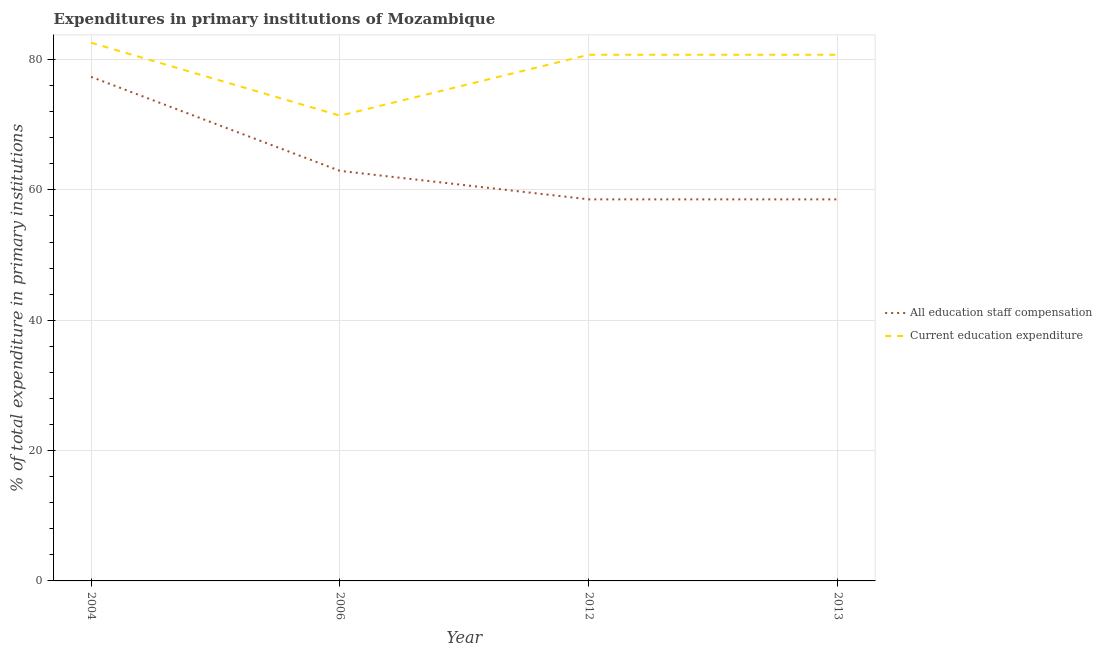Does the line corresponding to expenditure in staff compensation intersect with the line corresponding to expenditure in education?
Ensure brevity in your answer.  No. Is the number of lines equal to the number of legend labels?
Offer a terse response. Yes. What is the expenditure in staff compensation in 2012?
Your response must be concise. 58.55. Across all years, what is the maximum expenditure in staff compensation?
Ensure brevity in your answer.  77.35. Across all years, what is the minimum expenditure in education?
Make the answer very short. 71.39. In which year was the expenditure in education maximum?
Make the answer very short. 2004. What is the total expenditure in education in the graph?
Offer a very short reply. 315.46. What is the difference between the expenditure in staff compensation in 2004 and that in 2006?
Provide a short and direct response. 14.43. What is the difference between the expenditure in education in 2004 and the expenditure in staff compensation in 2013?
Your answer should be compact. 24.04. What is the average expenditure in education per year?
Provide a short and direct response. 78.87. In the year 2013, what is the difference between the expenditure in staff compensation and expenditure in education?
Provide a succinct answer. -22.19. What is the ratio of the expenditure in staff compensation in 2006 to that in 2012?
Keep it short and to the point. 1.07. Is the difference between the expenditure in staff compensation in 2004 and 2006 greater than the difference between the expenditure in education in 2004 and 2006?
Make the answer very short. Yes. What is the difference between the highest and the second highest expenditure in education?
Offer a terse response. 1.85. What is the difference between the highest and the lowest expenditure in staff compensation?
Offer a terse response. 18.8. In how many years, is the expenditure in education greater than the average expenditure in education taken over all years?
Offer a very short reply. 3. How many years are there in the graph?
Give a very brief answer. 4. What is the difference between two consecutive major ticks on the Y-axis?
Your response must be concise. 20. Does the graph contain grids?
Provide a succinct answer. Yes. Where does the legend appear in the graph?
Offer a very short reply. Center right. How are the legend labels stacked?
Your answer should be compact. Vertical. What is the title of the graph?
Offer a terse response. Expenditures in primary institutions of Mozambique. What is the label or title of the Y-axis?
Ensure brevity in your answer.  % of total expenditure in primary institutions. What is the % of total expenditure in primary institutions of All education staff compensation in 2004?
Make the answer very short. 77.35. What is the % of total expenditure in primary institutions of Current education expenditure in 2004?
Provide a succinct answer. 82.59. What is the % of total expenditure in primary institutions of All education staff compensation in 2006?
Offer a very short reply. 62.92. What is the % of total expenditure in primary institutions in Current education expenditure in 2006?
Offer a very short reply. 71.39. What is the % of total expenditure in primary institutions of All education staff compensation in 2012?
Provide a succinct answer. 58.55. What is the % of total expenditure in primary institutions of Current education expenditure in 2012?
Your response must be concise. 80.74. What is the % of total expenditure in primary institutions in All education staff compensation in 2013?
Your answer should be compact. 58.55. What is the % of total expenditure in primary institutions of Current education expenditure in 2013?
Your answer should be very brief. 80.74. Across all years, what is the maximum % of total expenditure in primary institutions of All education staff compensation?
Keep it short and to the point. 77.35. Across all years, what is the maximum % of total expenditure in primary institutions in Current education expenditure?
Provide a succinct answer. 82.59. Across all years, what is the minimum % of total expenditure in primary institutions in All education staff compensation?
Provide a succinct answer. 58.55. Across all years, what is the minimum % of total expenditure in primary institutions in Current education expenditure?
Give a very brief answer. 71.39. What is the total % of total expenditure in primary institutions in All education staff compensation in the graph?
Make the answer very short. 257.37. What is the total % of total expenditure in primary institutions of Current education expenditure in the graph?
Offer a very short reply. 315.46. What is the difference between the % of total expenditure in primary institutions of All education staff compensation in 2004 and that in 2006?
Give a very brief answer. 14.43. What is the difference between the % of total expenditure in primary institutions in Current education expenditure in 2004 and that in 2006?
Offer a terse response. 11.19. What is the difference between the % of total expenditure in primary institutions in All education staff compensation in 2004 and that in 2012?
Give a very brief answer. 18.8. What is the difference between the % of total expenditure in primary institutions in Current education expenditure in 2004 and that in 2012?
Ensure brevity in your answer.  1.85. What is the difference between the % of total expenditure in primary institutions of All education staff compensation in 2004 and that in 2013?
Ensure brevity in your answer.  18.8. What is the difference between the % of total expenditure in primary institutions of Current education expenditure in 2004 and that in 2013?
Provide a succinct answer. 1.85. What is the difference between the % of total expenditure in primary institutions in All education staff compensation in 2006 and that in 2012?
Provide a succinct answer. 4.37. What is the difference between the % of total expenditure in primary institutions in Current education expenditure in 2006 and that in 2012?
Provide a succinct answer. -9.35. What is the difference between the % of total expenditure in primary institutions of All education staff compensation in 2006 and that in 2013?
Make the answer very short. 4.37. What is the difference between the % of total expenditure in primary institutions in Current education expenditure in 2006 and that in 2013?
Offer a very short reply. -9.35. What is the difference between the % of total expenditure in primary institutions in All education staff compensation in 2012 and that in 2013?
Ensure brevity in your answer.  0. What is the difference between the % of total expenditure in primary institutions of All education staff compensation in 2004 and the % of total expenditure in primary institutions of Current education expenditure in 2006?
Ensure brevity in your answer.  5.96. What is the difference between the % of total expenditure in primary institutions in All education staff compensation in 2004 and the % of total expenditure in primary institutions in Current education expenditure in 2012?
Offer a very short reply. -3.39. What is the difference between the % of total expenditure in primary institutions in All education staff compensation in 2004 and the % of total expenditure in primary institutions in Current education expenditure in 2013?
Keep it short and to the point. -3.39. What is the difference between the % of total expenditure in primary institutions in All education staff compensation in 2006 and the % of total expenditure in primary institutions in Current education expenditure in 2012?
Your answer should be very brief. -17.82. What is the difference between the % of total expenditure in primary institutions of All education staff compensation in 2006 and the % of total expenditure in primary institutions of Current education expenditure in 2013?
Ensure brevity in your answer.  -17.82. What is the difference between the % of total expenditure in primary institutions in All education staff compensation in 2012 and the % of total expenditure in primary institutions in Current education expenditure in 2013?
Your answer should be very brief. -22.19. What is the average % of total expenditure in primary institutions of All education staff compensation per year?
Offer a terse response. 64.34. What is the average % of total expenditure in primary institutions in Current education expenditure per year?
Offer a very short reply. 78.87. In the year 2004, what is the difference between the % of total expenditure in primary institutions of All education staff compensation and % of total expenditure in primary institutions of Current education expenditure?
Give a very brief answer. -5.24. In the year 2006, what is the difference between the % of total expenditure in primary institutions in All education staff compensation and % of total expenditure in primary institutions in Current education expenditure?
Your answer should be compact. -8.47. In the year 2012, what is the difference between the % of total expenditure in primary institutions of All education staff compensation and % of total expenditure in primary institutions of Current education expenditure?
Keep it short and to the point. -22.19. In the year 2013, what is the difference between the % of total expenditure in primary institutions in All education staff compensation and % of total expenditure in primary institutions in Current education expenditure?
Provide a short and direct response. -22.19. What is the ratio of the % of total expenditure in primary institutions of All education staff compensation in 2004 to that in 2006?
Offer a very short reply. 1.23. What is the ratio of the % of total expenditure in primary institutions in Current education expenditure in 2004 to that in 2006?
Your answer should be compact. 1.16. What is the ratio of the % of total expenditure in primary institutions of All education staff compensation in 2004 to that in 2012?
Keep it short and to the point. 1.32. What is the ratio of the % of total expenditure in primary institutions in Current education expenditure in 2004 to that in 2012?
Offer a terse response. 1.02. What is the ratio of the % of total expenditure in primary institutions of All education staff compensation in 2004 to that in 2013?
Ensure brevity in your answer.  1.32. What is the ratio of the % of total expenditure in primary institutions in Current education expenditure in 2004 to that in 2013?
Provide a short and direct response. 1.02. What is the ratio of the % of total expenditure in primary institutions in All education staff compensation in 2006 to that in 2012?
Provide a succinct answer. 1.07. What is the ratio of the % of total expenditure in primary institutions in Current education expenditure in 2006 to that in 2012?
Make the answer very short. 0.88. What is the ratio of the % of total expenditure in primary institutions in All education staff compensation in 2006 to that in 2013?
Offer a terse response. 1.07. What is the ratio of the % of total expenditure in primary institutions of Current education expenditure in 2006 to that in 2013?
Your answer should be compact. 0.88. What is the ratio of the % of total expenditure in primary institutions of All education staff compensation in 2012 to that in 2013?
Your answer should be very brief. 1. What is the ratio of the % of total expenditure in primary institutions of Current education expenditure in 2012 to that in 2013?
Offer a terse response. 1. What is the difference between the highest and the second highest % of total expenditure in primary institutions in All education staff compensation?
Give a very brief answer. 14.43. What is the difference between the highest and the second highest % of total expenditure in primary institutions of Current education expenditure?
Ensure brevity in your answer.  1.85. What is the difference between the highest and the lowest % of total expenditure in primary institutions in All education staff compensation?
Provide a short and direct response. 18.8. What is the difference between the highest and the lowest % of total expenditure in primary institutions of Current education expenditure?
Ensure brevity in your answer.  11.19. 